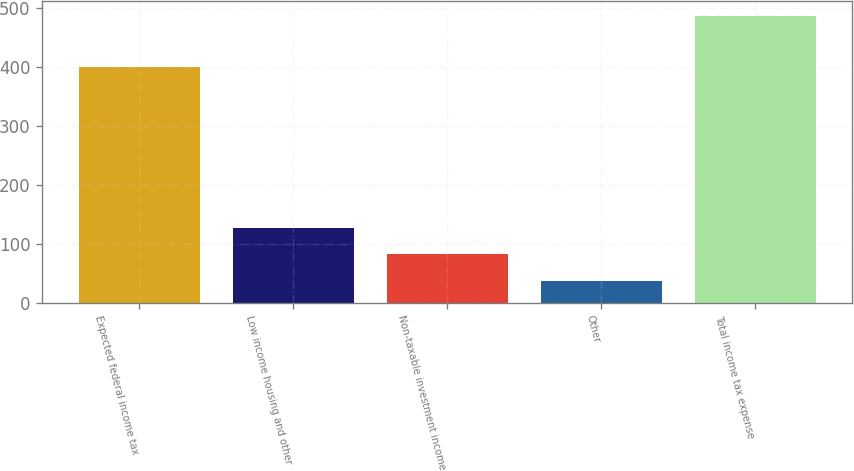<chart> <loc_0><loc_0><loc_500><loc_500><bar_chart><fcel>Expected federal income tax<fcel>Low income housing and other<fcel>Non-taxable investment income<fcel>Other<fcel>Total income tax expense<nl><fcel>399<fcel>127<fcel>82<fcel>37<fcel>487<nl></chart> 